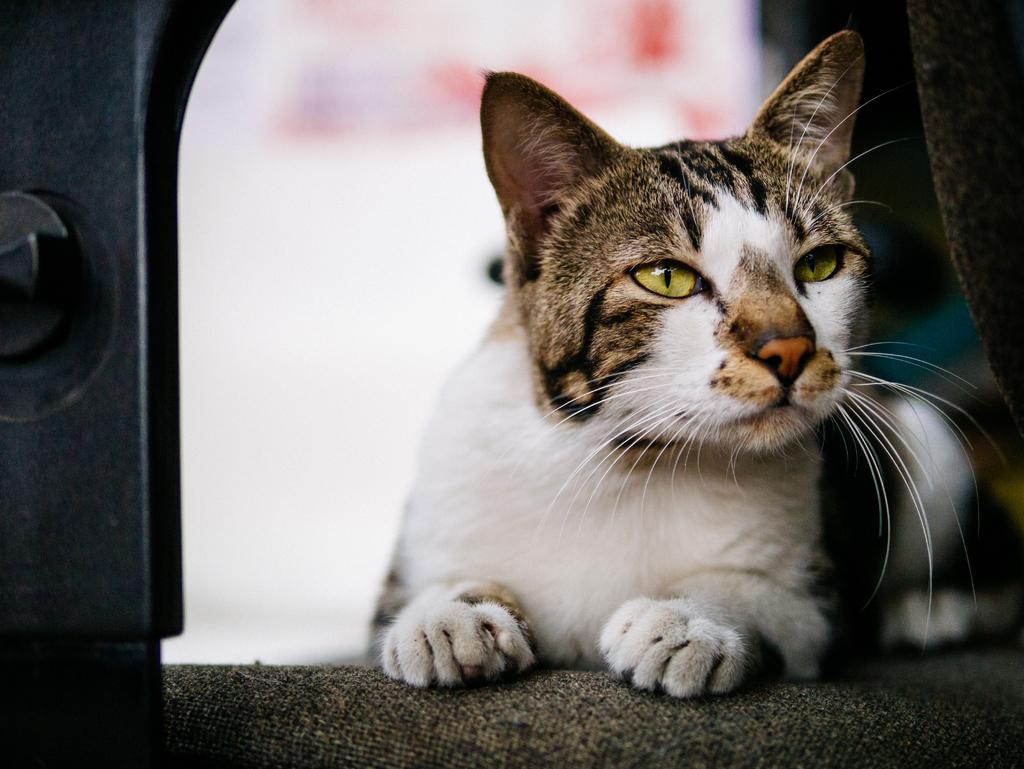In one or two sentences, can you explain what this image depicts? In the picture we can see a cat sitting on the mat surface, the cat is white in color with some black lines on it. 